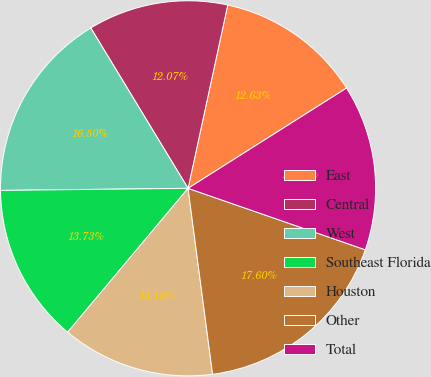<chart> <loc_0><loc_0><loc_500><loc_500><pie_chart><fcel>East<fcel>Central<fcel>West<fcel>Southeast Florida<fcel>Houston<fcel>Other<fcel>Total<nl><fcel>12.63%<fcel>12.07%<fcel>16.5%<fcel>13.73%<fcel>13.18%<fcel>17.6%<fcel>14.29%<nl></chart> 